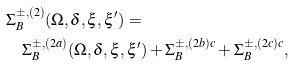<formula> <loc_0><loc_0><loc_500><loc_500>& \Sigma _ { B } ^ { \pm , ( 2 ) } ( \Omega , \delta , \xi , \xi ^ { \prime } ) = \\ & \quad \Sigma _ { B } ^ { \pm , ( 2 a ) } ( \Omega , \delta , \xi , \xi ^ { \prime } ) + \Sigma _ { B } ^ { \pm , ( 2 b ) c } + \Sigma _ { B } ^ { \pm , ( 2 c ) c } ,</formula> 